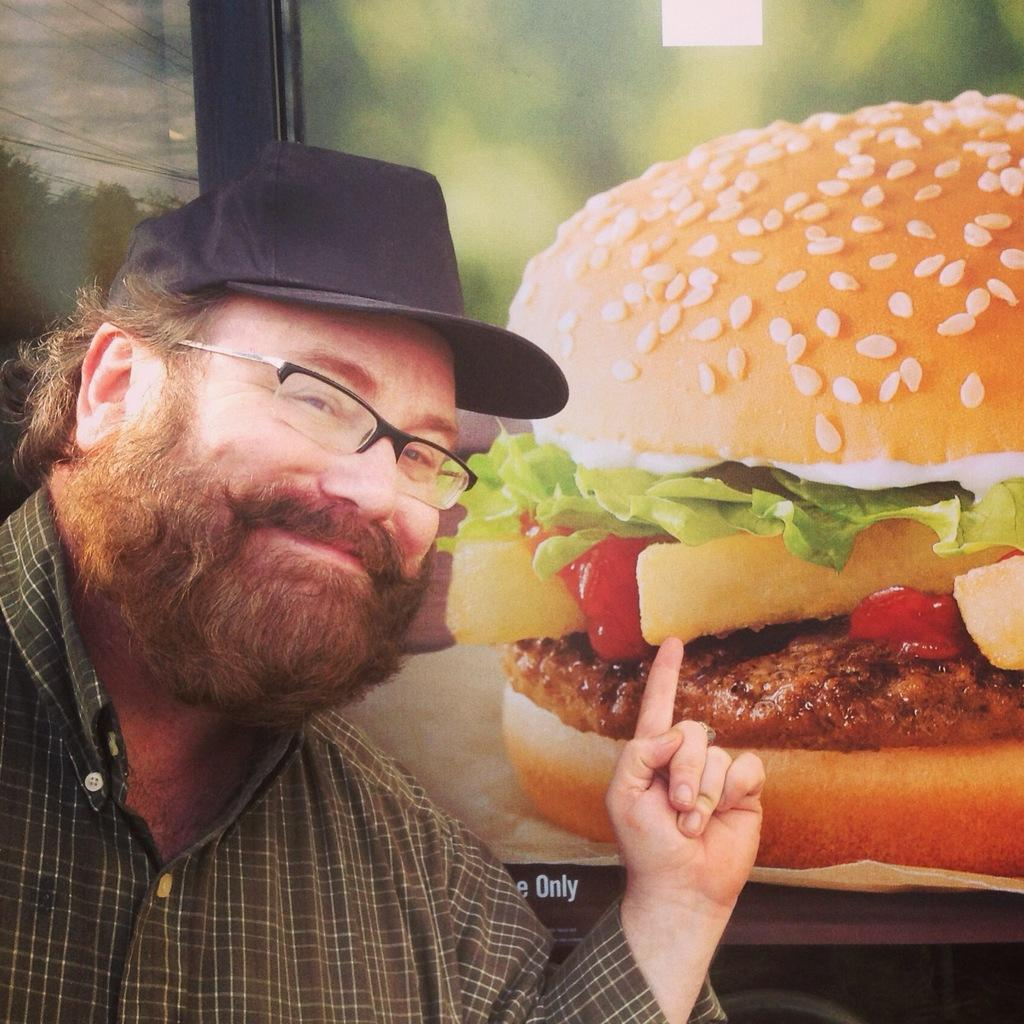Who is present in the image? There is a man in the image. What is the man doing with his finger? The man is pointing his finger upward. What accessories is the man wearing? The man is wearing a cap, spectacles, and a shirt. What can be seen in the background of the image? There is a photo of a burger in the background of the image. How does the man use the whip in the image? There is no whip present in the image; the man is pointing his finger upward and wearing a cap, spectacles, and a shirt. 